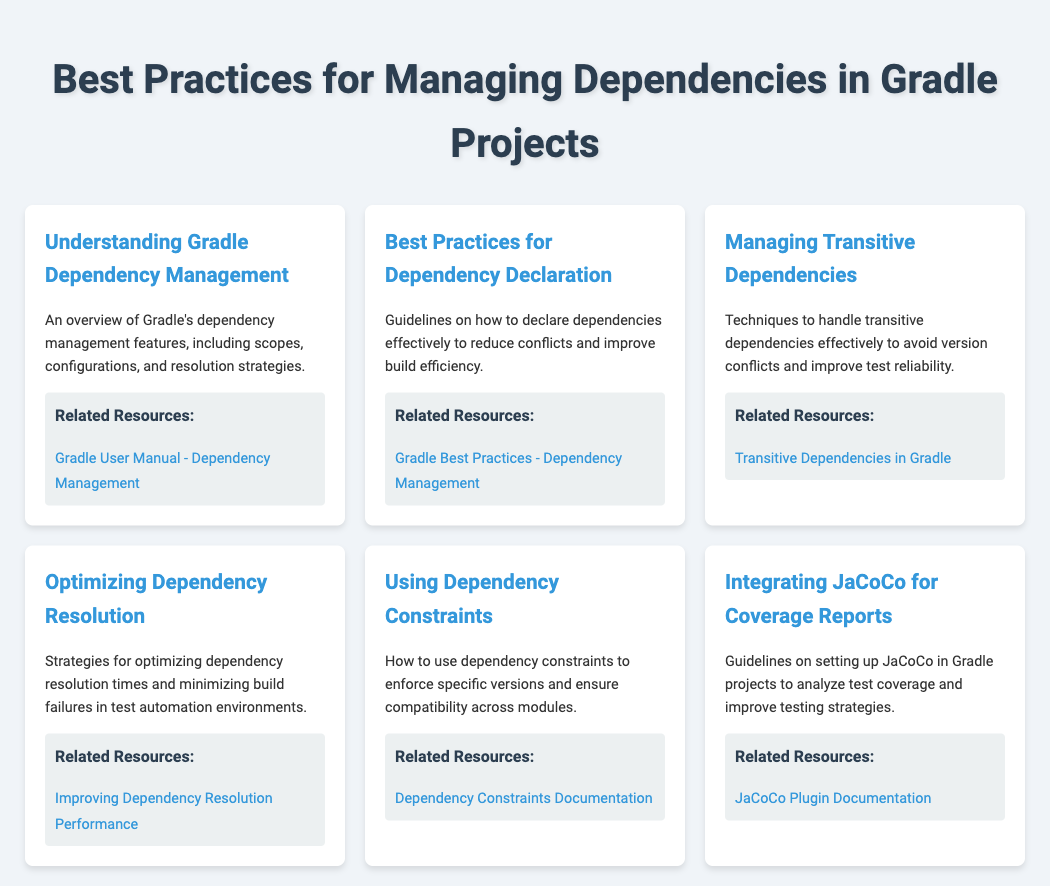what is the title of the document? The title of the document is specified in the head section and appears at the top of the rendered page.
Answer: Best Practices for Managing Dependencies in Gradle Projects how many menu items are there? The number of menu items is determined by counting the sections in the menu of the rendered document.
Answer: Six what topic does the last menu item cover? The last menu item title provides insight into the content it covers.
Answer: Integrating JaCoCo for Coverage Reports which resource provides information on managing transitive dependencies? The resource link associated with the menu item helps in identifying the relevant documentation for transitive dependencies.
Answer: Transitive Dependencies in Gradle what is a focus area mentioned under optimizing dependency resolution? A focus area is mentioned in the description of the menu item for optimizing dependency resolution.
Answer: Minimizing build failures what does the Best Practices for Dependency Declaration aim to achieve? The description specifies that this section aims at improving a particular aspect of project dependencies.
Answer: Reduce conflicts and improve build efficiency how many resources are linked in total across all menu items? The total number of resources can be found by counting the resources listed under each menu item.
Answer: Six 